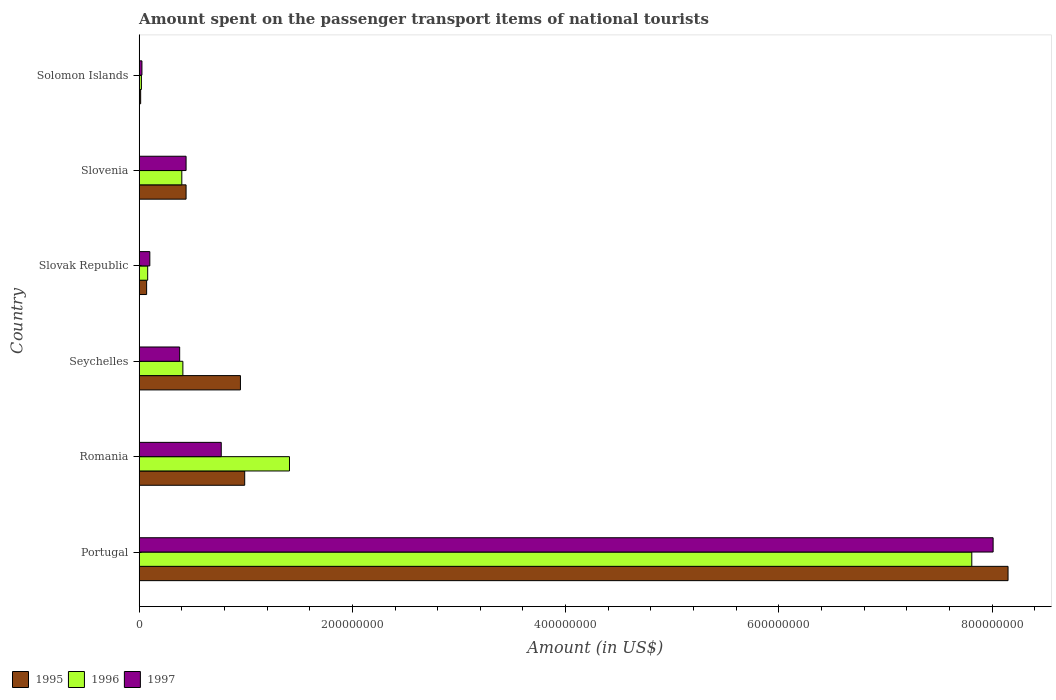How many different coloured bars are there?
Keep it short and to the point. 3. Are the number of bars on each tick of the Y-axis equal?
Offer a very short reply. Yes. What is the label of the 3rd group of bars from the top?
Provide a succinct answer. Slovak Republic. In how many cases, is the number of bars for a given country not equal to the number of legend labels?
Provide a succinct answer. 0. What is the amount spent on the passenger transport items of national tourists in 1997 in Solomon Islands?
Your response must be concise. 2.60e+06. Across all countries, what is the maximum amount spent on the passenger transport items of national tourists in 1995?
Your answer should be compact. 8.15e+08. Across all countries, what is the minimum amount spent on the passenger transport items of national tourists in 1997?
Your answer should be very brief. 2.60e+06. In which country was the amount spent on the passenger transport items of national tourists in 1995 minimum?
Offer a very short reply. Solomon Islands. What is the total amount spent on the passenger transport items of national tourists in 1996 in the graph?
Provide a short and direct response. 1.01e+09. What is the difference between the amount spent on the passenger transport items of national tourists in 1995 in Slovak Republic and that in Slovenia?
Offer a terse response. -3.70e+07. What is the difference between the amount spent on the passenger transport items of national tourists in 1995 in Slovenia and the amount spent on the passenger transport items of national tourists in 1997 in Portugal?
Offer a terse response. -7.57e+08. What is the average amount spent on the passenger transport items of national tourists in 1995 per country?
Offer a very short reply. 1.77e+08. What is the ratio of the amount spent on the passenger transport items of national tourists in 1995 in Portugal to that in Seychelles?
Your response must be concise. 8.58. Is the amount spent on the passenger transport items of national tourists in 1996 in Romania less than that in Slovak Republic?
Offer a very short reply. No. Is the difference between the amount spent on the passenger transport items of national tourists in 1996 in Slovak Republic and Slovenia greater than the difference between the amount spent on the passenger transport items of national tourists in 1995 in Slovak Republic and Slovenia?
Give a very brief answer. Yes. What is the difference between the highest and the second highest amount spent on the passenger transport items of national tourists in 1996?
Ensure brevity in your answer.  6.40e+08. What is the difference between the highest and the lowest amount spent on the passenger transport items of national tourists in 1995?
Your answer should be compact. 8.14e+08. Is the sum of the amount spent on the passenger transport items of national tourists in 1996 in Portugal and Romania greater than the maximum amount spent on the passenger transport items of national tourists in 1997 across all countries?
Your answer should be very brief. Yes. Is it the case that in every country, the sum of the amount spent on the passenger transport items of national tourists in 1997 and amount spent on the passenger transport items of national tourists in 1996 is greater than the amount spent on the passenger transport items of national tourists in 1995?
Provide a short and direct response. No. How many bars are there?
Provide a succinct answer. 18. Are all the bars in the graph horizontal?
Your response must be concise. Yes. How many countries are there in the graph?
Make the answer very short. 6. Does the graph contain any zero values?
Your answer should be very brief. No. What is the title of the graph?
Your response must be concise. Amount spent on the passenger transport items of national tourists. Does "1997" appear as one of the legend labels in the graph?
Your response must be concise. Yes. What is the Amount (in US$) of 1995 in Portugal?
Provide a succinct answer. 8.15e+08. What is the Amount (in US$) in 1996 in Portugal?
Ensure brevity in your answer.  7.81e+08. What is the Amount (in US$) of 1997 in Portugal?
Your answer should be very brief. 8.01e+08. What is the Amount (in US$) in 1995 in Romania?
Offer a very short reply. 9.90e+07. What is the Amount (in US$) of 1996 in Romania?
Make the answer very short. 1.41e+08. What is the Amount (in US$) in 1997 in Romania?
Offer a very short reply. 7.70e+07. What is the Amount (in US$) of 1995 in Seychelles?
Offer a terse response. 9.50e+07. What is the Amount (in US$) in 1996 in Seychelles?
Keep it short and to the point. 4.10e+07. What is the Amount (in US$) in 1997 in Seychelles?
Give a very brief answer. 3.80e+07. What is the Amount (in US$) in 1996 in Slovak Republic?
Your answer should be very brief. 8.00e+06. What is the Amount (in US$) in 1995 in Slovenia?
Provide a succinct answer. 4.40e+07. What is the Amount (in US$) of 1996 in Slovenia?
Offer a terse response. 4.00e+07. What is the Amount (in US$) of 1997 in Slovenia?
Make the answer very short. 4.40e+07. What is the Amount (in US$) in 1995 in Solomon Islands?
Provide a short and direct response. 1.40e+06. What is the Amount (in US$) of 1996 in Solomon Islands?
Provide a succinct answer. 2.10e+06. What is the Amount (in US$) of 1997 in Solomon Islands?
Your answer should be compact. 2.60e+06. Across all countries, what is the maximum Amount (in US$) of 1995?
Make the answer very short. 8.15e+08. Across all countries, what is the maximum Amount (in US$) in 1996?
Your answer should be compact. 7.81e+08. Across all countries, what is the maximum Amount (in US$) of 1997?
Your answer should be very brief. 8.01e+08. Across all countries, what is the minimum Amount (in US$) in 1995?
Give a very brief answer. 1.40e+06. Across all countries, what is the minimum Amount (in US$) of 1996?
Your response must be concise. 2.10e+06. Across all countries, what is the minimum Amount (in US$) in 1997?
Make the answer very short. 2.60e+06. What is the total Amount (in US$) in 1995 in the graph?
Your answer should be very brief. 1.06e+09. What is the total Amount (in US$) of 1996 in the graph?
Your response must be concise. 1.01e+09. What is the total Amount (in US$) of 1997 in the graph?
Provide a short and direct response. 9.73e+08. What is the difference between the Amount (in US$) in 1995 in Portugal and that in Romania?
Provide a short and direct response. 7.16e+08. What is the difference between the Amount (in US$) of 1996 in Portugal and that in Romania?
Ensure brevity in your answer.  6.40e+08. What is the difference between the Amount (in US$) in 1997 in Portugal and that in Romania?
Offer a very short reply. 7.24e+08. What is the difference between the Amount (in US$) in 1995 in Portugal and that in Seychelles?
Keep it short and to the point. 7.20e+08. What is the difference between the Amount (in US$) in 1996 in Portugal and that in Seychelles?
Provide a succinct answer. 7.40e+08. What is the difference between the Amount (in US$) of 1997 in Portugal and that in Seychelles?
Offer a very short reply. 7.63e+08. What is the difference between the Amount (in US$) of 1995 in Portugal and that in Slovak Republic?
Keep it short and to the point. 8.08e+08. What is the difference between the Amount (in US$) of 1996 in Portugal and that in Slovak Republic?
Make the answer very short. 7.73e+08. What is the difference between the Amount (in US$) of 1997 in Portugal and that in Slovak Republic?
Make the answer very short. 7.91e+08. What is the difference between the Amount (in US$) in 1995 in Portugal and that in Slovenia?
Offer a terse response. 7.71e+08. What is the difference between the Amount (in US$) in 1996 in Portugal and that in Slovenia?
Your response must be concise. 7.41e+08. What is the difference between the Amount (in US$) in 1997 in Portugal and that in Slovenia?
Offer a very short reply. 7.57e+08. What is the difference between the Amount (in US$) of 1995 in Portugal and that in Solomon Islands?
Provide a short and direct response. 8.14e+08. What is the difference between the Amount (in US$) in 1996 in Portugal and that in Solomon Islands?
Provide a short and direct response. 7.79e+08. What is the difference between the Amount (in US$) of 1997 in Portugal and that in Solomon Islands?
Your answer should be very brief. 7.98e+08. What is the difference between the Amount (in US$) of 1995 in Romania and that in Seychelles?
Your response must be concise. 4.00e+06. What is the difference between the Amount (in US$) of 1996 in Romania and that in Seychelles?
Provide a succinct answer. 1.00e+08. What is the difference between the Amount (in US$) in 1997 in Romania and that in Seychelles?
Provide a short and direct response. 3.90e+07. What is the difference between the Amount (in US$) of 1995 in Romania and that in Slovak Republic?
Offer a very short reply. 9.20e+07. What is the difference between the Amount (in US$) in 1996 in Romania and that in Slovak Republic?
Offer a terse response. 1.33e+08. What is the difference between the Amount (in US$) of 1997 in Romania and that in Slovak Republic?
Offer a very short reply. 6.70e+07. What is the difference between the Amount (in US$) of 1995 in Romania and that in Slovenia?
Offer a very short reply. 5.50e+07. What is the difference between the Amount (in US$) in 1996 in Romania and that in Slovenia?
Offer a terse response. 1.01e+08. What is the difference between the Amount (in US$) of 1997 in Romania and that in Slovenia?
Offer a very short reply. 3.30e+07. What is the difference between the Amount (in US$) of 1995 in Romania and that in Solomon Islands?
Give a very brief answer. 9.76e+07. What is the difference between the Amount (in US$) of 1996 in Romania and that in Solomon Islands?
Ensure brevity in your answer.  1.39e+08. What is the difference between the Amount (in US$) of 1997 in Romania and that in Solomon Islands?
Give a very brief answer. 7.44e+07. What is the difference between the Amount (in US$) in 1995 in Seychelles and that in Slovak Republic?
Your response must be concise. 8.80e+07. What is the difference between the Amount (in US$) of 1996 in Seychelles and that in Slovak Republic?
Your answer should be compact. 3.30e+07. What is the difference between the Amount (in US$) in 1997 in Seychelles and that in Slovak Republic?
Keep it short and to the point. 2.80e+07. What is the difference between the Amount (in US$) in 1995 in Seychelles and that in Slovenia?
Keep it short and to the point. 5.10e+07. What is the difference between the Amount (in US$) in 1996 in Seychelles and that in Slovenia?
Provide a succinct answer. 1.00e+06. What is the difference between the Amount (in US$) in 1997 in Seychelles and that in Slovenia?
Make the answer very short. -6.00e+06. What is the difference between the Amount (in US$) in 1995 in Seychelles and that in Solomon Islands?
Provide a succinct answer. 9.36e+07. What is the difference between the Amount (in US$) in 1996 in Seychelles and that in Solomon Islands?
Make the answer very short. 3.89e+07. What is the difference between the Amount (in US$) of 1997 in Seychelles and that in Solomon Islands?
Ensure brevity in your answer.  3.54e+07. What is the difference between the Amount (in US$) in 1995 in Slovak Republic and that in Slovenia?
Offer a very short reply. -3.70e+07. What is the difference between the Amount (in US$) of 1996 in Slovak Republic and that in Slovenia?
Your response must be concise. -3.20e+07. What is the difference between the Amount (in US$) in 1997 in Slovak Republic and that in Slovenia?
Make the answer very short. -3.40e+07. What is the difference between the Amount (in US$) of 1995 in Slovak Republic and that in Solomon Islands?
Your response must be concise. 5.60e+06. What is the difference between the Amount (in US$) in 1996 in Slovak Republic and that in Solomon Islands?
Your response must be concise. 5.90e+06. What is the difference between the Amount (in US$) of 1997 in Slovak Republic and that in Solomon Islands?
Offer a terse response. 7.40e+06. What is the difference between the Amount (in US$) of 1995 in Slovenia and that in Solomon Islands?
Make the answer very short. 4.26e+07. What is the difference between the Amount (in US$) of 1996 in Slovenia and that in Solomon Islands?
Your answer should be very brief. 3.79e+07. What is the difference between the Amount (in US$) in 1997 in Slovenia and that in Solomon Islands?
Keep it short and to the point. 4.14e+07. What is the difference between the Amount (in US$) in 1995 in Portugal and the Amount (in US$) in 1996 in Romania?
Your answer should be very brief. 6.74e+08. What is the difference between the Amount (in US$) of 1995 in Portugal and the Amount (in US$) of 1997 in Romania?
Your response must be concise. 7.38e+08. What is the difference between the Amount (in US$) of 1996 in Portugal and the Amount (in US$) of 1997 in Romania?
Offer a terse response. 7.04e+08. What is the difference between the Amount (in US$) in 1995 in Portugal and the Amount (in US$) in 1996 in Seychelles?
Keep it short and to the point. 7.74e+08. What is the difference between the Amount (in US$) in 1995 in Portugal and the Amount (in US$) in 1997 in Seychelles?
Your answer should be very brief. 7.77e+08. What is the difference between the Amount (in US$) in 1996 in Portugal and the Amount (in US$) in 1997 in Seychelles?
Ensure brevity in your answer.  7.43e+08. What is the difference between the Amount (in US$) of 1995 in Portugal and the Amount (in US$) of 1996 in Slovak Republic?
Make the answer very short. 8.07e+08. What is the difference between the Amount (in US$) in 1995 in Portugal and the Amount (in US$) in 1997 in Slovak Republic?
Make the answer very short. 8.05e+08. What is the difference between the Amount (in US$) in 1996 in Portugal and the Amount (in US$) in 1997 in Slovak Republic?
Your answer should be very brief. 7.71e+08. What is the difference between the Amount (in US$) in 1995 in Portugal and the Amount (in US$) in 1996 in Slovenia?
Provide a succinct answer. 7.75e+08. What is the difference between the Amount (in US$) of 1995 in Portugal and the Amount (in US$) of 1997 in Slovenia?
Provide a short and direct response. 7.71e+08. What is the difference between the Amount (in US$) in 1996 in Portugal and the Amount (in US$) in 1997 in Slovenia?
Provide a short and direct response. 7.37e+08. What is the difference between the Amount (in US$) of 1995 in Portugal and the Amount (in US$) of 1996 in Solomon Islands?
Ensure brevity in your answer.  8.13e+08. What is the difference between the Amount (in US$) in 1995 in Portugal and the Amount (in US$) in 1997 in Solomon Islands?
Provide a succinct answer. 8.12e+08. What is the difference between the Amount (in US$) in 1996 in Portugal and the Amount (in US$) in 1997 in Solomon Islands?
Your response must be concise. 7.78e+08. What is the difference between the Amount (in US$) of 1995 in Romania and the Amount (in US$) of 1996 in Seychelles?
Ensure brevity in your answer.  5.80e+07. What is the difference between the Amount (in US$) in 1995 in Romania and the Amount (in US$) in 1997 in Seychelles?
Your answer should be very brief. 6.10e+07. What is the difference between the Amount (in US$) of 1996 in Romania and the Amount (in US$) of 1997 in Seychelles?
Your response must be concise. 1.03e+08. What is the difference between the Amount (in US$) of 1995 in Romania and the Amount (in US$) of 1996 in Slovak Republic?
Keep it short and to the point. 9.10e+07. What is the difference between the Amount (in US$) of 1995 in Romania and the Amount (in US$) of 1997 in Slovak Republic?
Offer a very short reply. 8.90e+07. What is the difference between the Amount (in US$) in 1996 in Romania and the Amount (in US$) in 1997 in Slovak Republic?
Your answer should be compact. 1.31e+08. What is the difference between the Amount (in US$) in 1995 in Romania and the Amount (in US$) in 1996 in Slovenia?
Give a very brief answer. 5.90e+07. What is the difference between the Amount (in US$) of 1995 in Romania and the Amount (in US$) of 1997 in Slovenia?
Provide a succinct answer. 5.50e+07. What is the difference between the Amount (in US$) of 1996 in Romania and the Amount (in US$) of 1997 in Slovenia?
Offer a very short reply. 9.70e+07. What is the difference between the Amount (in US$) of 1995 in Romania and the Amount (in US$) of 1996 in Solomon Islands?
Your response must be concise. 9.69e+07. What is the difference between the Amount (in US$) in 1995 in Romania and the Amount (in US$) in 1997 in Solomon Islands?
Your answer should be very brief. 9.64e+07. What is the difference between the Amount (in US$) of 1996 in Romania and the Amount (in US$) of 1997 in Solomon Islands?
Your answer should be very brief. 1.38e+08. What is the difference between the Amount (in US$) of 1995 in Seychelles and the Amount (in US$) of 1996 in Slovak Republic?
Ensure brevity in your answer.  8.70e+07. What is the difference between the Amount (in US$) of 1995 in Seychelles and the Amount (in US$) of 1997 in Slovak Republic?
Provide a short and direct response. 8.50e+07. What is the difference between the Amount (in US$) in 1996 in Seychelles and the Amount (in US$) in 1997 in Slovak Republic?
Your answer should be compact. 3.10e+07. What is the difference between the Amount (in US$) in 1995 in Seychelles and the Amount (in US$) in 1996 in Slovenia?
Your response must be concise. 5.50e+07. What is the difference between the Amount (in US$) in 1995 in Seychelles and the Amount (in US$) in 1997 in Slovenia?
Your answer should be compact. 5.10e+07. What is the difference between the Amount (in US$) in 1996 in Seychelles and the Amount (in US$) in 1997 in Slovenia?
Your answer should be compact. -3.00e+06. What is the difference between the Amount (in US$) of 1995 in Seychelles and the Amount (in US$) of 1996 in Solomon Islands?
Offer a very short reply. 9.29e+07. What is the difference between the Amount (in US$) in 1995 in Seychelles and the Amount (in US$) in 1997 in Solomon Islands?
Your answer should be compact. 9.24e+07. What is the difference between the Amount (in US$) in 1996 in Seychelles and the Amount (in US$) in 1997 in Solomon Islands?
Your answer should be compact. 3.84e+07. What is the difference between the Amount (in US$) of 1995 in Slovak Republic and the Amount (in US$) of 1996 in Slovenia?
Ensure brevity in your answer.  -3.30e+07. What is the difference between the Amount (in US$) of 1995 in Slovak Republic and the Amount (in US$) of 1997 in Slovenia?
Your response must be concise. -3.70e+07. What is the difference between the Amount (in US$) in 1996 in Slovak Republic and the Amount (in US$) in 1997 in Slovenia?
Your answer should be compact. -3.60e+07. What is the difference between the Amount (in US$) of 1995 in Slovak Republic and the Amount (in US$) of 1996 in Solomon Islands?
Make the answer very short. 4.90e+06. What is the difference between the Amount (in US$) of 1995 in Slovak Republic and the Amount (in US$) of 1997 in Solomon Islands?
Keep it short and to the point. 4.40e+06. What is the difference between the Amount (in US$) in 1996 in Slovak Republic and the Amount (in US$) in 1997 in Solomon Islands?
Your answer should be compact. 5.40e+06. What is the difference between the Amount (in US$) of 1995 in Slovenia and the Amount (in US$) of 1996 in Solomon Islands?
Provide a succinct answer. 4.19e+07. What is the difference between the Amount (in US$) of 1995 in Slovenia and the Amount (in US$) of 1997 in Solomon Islands?
Offer a terse response. 4.14e+07. What is the difference between the Amount (in US$) in 1996 in Slovenia and the Amount (in US$) in 1997 in Solomon Islands?
Offer a very short reply. 3.74e+07. What is the average Amount (in US$) in 1995 per country?
Make the answer very short. 1.77e+08. What is the average Amount (in US$) in 1996 per country?
Offer a terse response. 1.69e+08. What is the average Amount (in US$) in 1997 per country?
Provide a succinct answer. 1.62e+08. What is the difference between the Amount (in US$) of 1995 and Amount (in US$) of 1996 in Portugal?
Offer a terse response. 3.40e+07. What is the difference between the Amount (in US$) in 1995 and Amount (in US$) in 1997 in Portugal?
Offer a terse response. 1.40e+07. What is the difference between the Amount (in US$) of 1996 and Amount (in US$) of 1997 in Portugal?
Make the answer very short. -2.00e+07. What is the difference between the Amount (in US$) in 1995 and Amount (in US$) in 1996 in Romania?
Provide a short and direct response. -4.20e+07. What is the difference between the Amount (in US$) in 1995 and Amount (in US$) in 1997 in Romania?
Your answer should be very brief. 2.20e+07. What is the difference between the Amount (in US$) in 1996 and Amount (in US$) in 1997 in Romania?
Your answer should be compact. 6.40e+07. What is the difference between the Amount (in US$) in 1995 and Amount (in US$) in 1996 in Seychelles?
Your response must be concise. 5.40e+07. What is the difference between the Amount (in US$) of 1995 and Amount (in US$) of 1997 in Seychelles?
Offer a very short reply. 5.70e+07. What is the difference between the Amount (in US$) of 1996 and Amount (in US$) of 1997 in Seychelles?
Your response must be concise. 3.00e+06. What is the difference between the Amount (in US$) of 1995 and Amount (in US$) of 1996 in Slovak Republic?
Give a very brief answer. -1.00e+06. What is the difference between the Amount (in US$) in 1996 and Amount (in US$) in 1997 in Slovak Republic?
Offer a very short reply. -2.00e+06. What is the difference between the Amount (in US$) in 1995 and Amount (in US$) in 1997 in Slovenia?
Provide a succinct answer. 0. What is the difference between the Amount (in US$) of 1995 and Amount (in US$) of 1996 in Solomon Islands?
Your response must be concise. -7.00e+05. What is the difference between the Amount (in US$) of 1995 and Amount (in US$) of 1997 in Solomon Islands?
Your answer should be compact. -1.20e+06. What is the difference between the Amount (in US$) of 1996 and Amount (in US$) of 1997 in Solomon Islands?
Offer a very short reply. -5.00e+05. What is the ratio of the Amount (in US$) in 1995 in Portugal to that in Romania?
Give a very brief answer. 8.23. What is the ratio of the Amount (in US$) in 1996 in Portugal to that in Romania?
Your answer should be very brief. 5.54. What is the ratio of the Amount (in US$) of 1997 in Portugal to that in Romania?
Your response must be concise. 10.4. What is the ratio of the Amount (in US$) of 1995 in Portugal to that in Seychelles?
Keep it short and to the point. 8.58. What is the ratio of the Amount (in US$) of 1996 in Portugal to that in Seychelles?
Your response must be concise. 19.05. What is the ratio of the Amount (in US$) in 1997 in Portugal to that in Seychelles?
Make the answer very short. 21.08. What is the ratio of the Amount (in US$) of 1995 in Portugal to that in Slovak Republic?
Make the answer very short. 116.43. What is the ratio of the Amount (in US$) of 1996 in Portugal to that in Slovak Republic?
Provide a short and direct response. 97.62. What is the ratio of the Amount (in US$) in 1997 in Portugal to that in Slovak Republic?
Give a very brief answer. 80.1. What is the ratio of the Amount (in US$) in 1995 in Portugal to that in Slovenia?
Your answer should be compact. 18.52. What is the ratio of the Amount (in US$) of 1996 in Portugal to that in Slovenia?
Ensure brevity in your answer.  19.52. What is the ratio of the Amount (in US$) in 1997 in Portugal to that in Slovenia?
Your response must be concise. 18.2. What is the ratio of the Amount (in US$) of 1995 in Portugal to that in Solomon Islands?
Your answer should be very brief. 582.14. What is the ratio of the Amount (in US$) in 1996 in Portugal to that in Solomon Islands?
Your answer should be very brief. 371.9. What is the ratio of the Amount (in US$) of 1997 in Portugal to that in Solomon Islands?
Offer a very short reply. 308.08. What is the ratio of the Amount (in US$) in 1995 in Romania to that in Seychelles?
Give a very brief answer. 1.04. What is the ratio of the Amount (in US$) of 1996 in Romania to that in Seychelles?
Offer a terse response. 3.44. What is the ratio of the Amount (in US$) in 1997 in Romania to that in Seychelles?
Give a very brief answer. 2.03. What is the ratio of the Amount (in US$) of 1995 in Romania to that in Slovak Republic?
Give a very brief answer. 14.14. What is the ratio of the Amount (in US$) of 1996 in Romania to that in Slovak Republic?
Your response must be concise. 17.62. What is the ratio of the Amount (in US$) in 1995 in Romania to that in Slovenia?
Your answer should be compact. 2.25. What is the ratio of the Amount (in US$) in 1996 in Romania to that in Slovenia?
Your answer should be compact. 3.52. What is the ratio of the Amount (in US$) in 1997 in Romania to that in Slovenia?
Your answer should be very brief. 1.75. What is the ratio of the Amount (in US$) of 1995 in Romania to that in Solomon Islands?
Provide a succinct answer. 70.71. What is the ratio of the Amount (in US$) in 1996 in Romania to that in Solomon Islands?
Your answer should be compact. 67.14. What is the ratio of the Amount (in US$) in 1997 in Romania to that in Solomon Islands?
Make the answer very short. 29.62. What is the ratio of the Amount (in US$) in 1995 in Seychelles to that in Slovak Republic?
Make the answer very short. 13.57. What is the ratio of the Amount (in US$) in 1996 in Seychelles to that in Slovak Republic?
Provide a short and direct response. 5.12. What is the ratio of the Amount (in US$) of 1995 in Seychelles to that in Slovenia?
Your answer should be very brief. 2.16. What is the ratio of the Amount (in US$) in 1996 in Seychelles to that in Slovenia?
Offer a very short reply. 1.02. What is the ratio of the Amount (in US$) in 1997 in Seychelles to that in Slovenia?
Ensure brevity in your answer.  0.86. What is the ratio of the Amount (in US$) in 1995 in Seychelles to that in Solomon Islands?
Offer a very short reply. 67.86. What is the ratio of the Amount (in US$) of 1996 in Seychelles to that in Solomon Islands?
Make the answer very short. 19.52. What is the ratio of the Amount (in US$) of 1997 in Seychelles to that in Solomon Islands?
Your response must be concise. 14.62. What is the ratio of the Amount (in US$) in 1995 in Slovak Republic to that in Slovenia?
Your response must be concise. 0.16. What is the ratio of the Amount (in US$) in 1997 in Slovak Republic to that in Slovenia?
Provide a short and direct response. 0.23. What is the ratio of the Amount (in US$) of 1996 in Slovak Republic to that in Solomon Islands?
Offer a terse response. 3.81. What is the ratio of the Amount (in US$) of 1997 in Slovak Republic to that in Solomon Islands?
Keep it short and to the point. 3.85. What is the ratio of the Amount (in US$) in 1995 in Slovenia to that in Solomon Islands?
Your answer should be very brief. 31.43. What is the ratio of the Amount (in US$) in 1996 in Slovenia to that in Solomon Islands?
Provide a short and direct response. 19.05. What is the ratio of the Amount (in US$) in 1997 in Slovenia to that in Solomon Islands?
Your answer should be very brief. 16.92. What is the difference between the highest and the second highest Amount (in US$) of 1995?
Your answer should be compact. 7.16e+08. What is the difference between the highest and the second highest Amount (in US$) of 1996?
Ensure brevity in your answer.  6.40e+08. What is the difference between the highest and the second highest Amount (in US$) of 1997?
Offer a terse response. 7.24e+08. What is the difference between the highest and the lowest Amount (in US$) in 1995?
Your answer should be compact. 8.14e+08. What is the difference between the highest and the lowest Amount (in US$) in 1996?
Ensure brevity in your answer.  7.79e+08. What is the difference between the highest and the lowest Amount (in US$) in 1997?
Your response must be concise. 7.98e+08. 